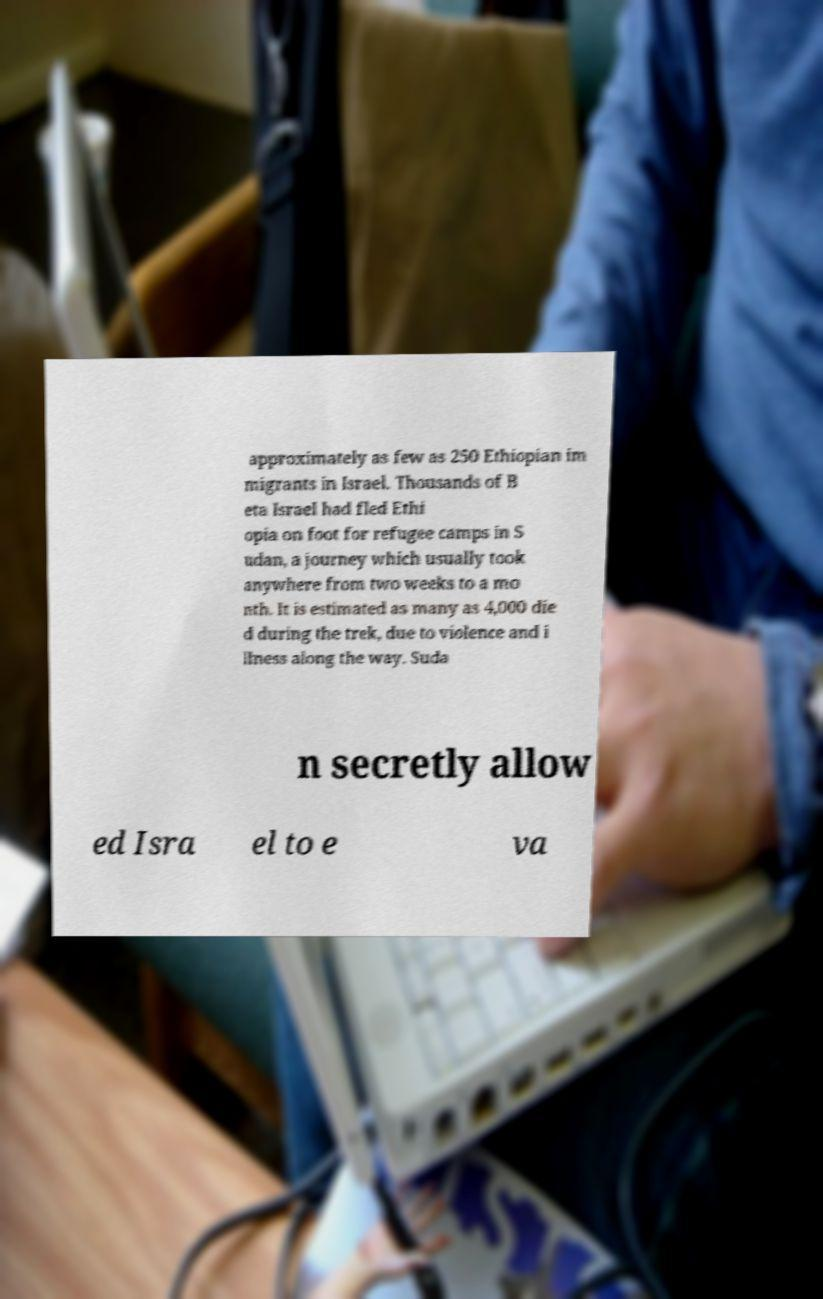Can you accurately transcribe the text from the provided image for me? approximately as few as 250 Ethiopian im migrants in Israel. Thousands of B eta Israel had fled Ethi opia on foot for refugee camps in S udan, a journey which usually took anywhere from two weeks to a mo nth. It is estimated as many as 4,000 die d during the trek, due to violence and i llness along the way. Suda n secretly allow ed Isra el to e va 